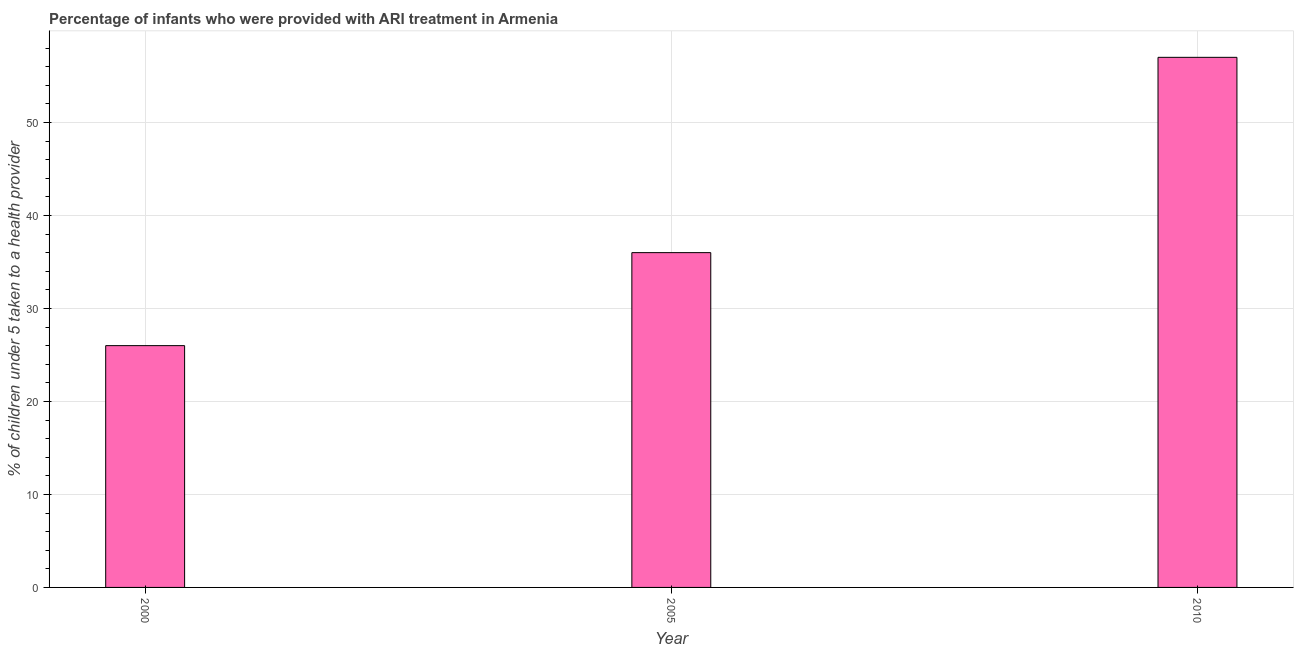What is the title of the graph?
Provide a succinct answer. Percentage of infants who were provided with ARI treatment in Armenia. What is the label or title of the Y-axis?
Offer a very short reply. % of children under 5 taken to a health provider. Across all years, what is the maximum percentage of children who were provided with ari treatment?
Your answer should be very brief. 57. What is the sum of the percentage of children who were provided with ari treatment?
Provide a short and direct response. 119. What is the difference between the percentage of children who were provided with ari treatment in 2005 and 2010?
Offer a terse response. -21. What is the median percentage of children who were provided with ari treatment?
Give a very brief answer. 36. What is the ratio of the percentage of children who were provided with ari treatment in 2005 to that in 2010?
Make the answer very short. 0.63. Is the percentage of children who were provided with ari treatment in 2005 less than that in 2010?
Give a very brief answer. Yes. In how many years, is the percentage of children who were provided with ari treatment greater than the average percentage of children who were provided with ari treatment taken over all years?
Offer a very short reply. 1. How many bars are there?
Provide a short and direct response. 3. How many years are there in the graph?
Give a very brief answer. 3. What is the difference between two consecutive major ticks on the Y-axis?
Your answer should be very brief. 10. Are the values on the major ticks of Y-axis written in scientific E-notation?
Keep it short and to the point. No. What is the % of children under 5 taken to a health provider in 2000?
Provide a short and direct response. 26. What is the % of children under 5 taken to a health provider of 2005?
Ensure brevity in your answer.  36. What is the difference between the % of children under 5 taken to a health provider in 2000 and 2010?
Make the answer very short. -31. What is the ratio of the % of children under 5 taken to a health provider in 2000 to that in 2005?
Provide a succinct answer. 0.72. What is the ratio of the % of children under 5 taken to a health provider in 2000 to that in 2010?
Provide a succinct answer. 0.46. What is the ratio of the % of children under 5 taken to a health provider in 2005 to that in 2010?
Keep it short and to the point. 0.63. 